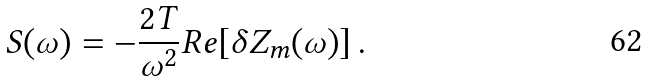<formula> <loc_0><loc_0><loc_500><loc_500>S ( \omega ) = - \frac { 2 T } { \omega ^ { 2 } } R e [ \delta Z _ { m } ( \omega ) ] \, .</formula> 